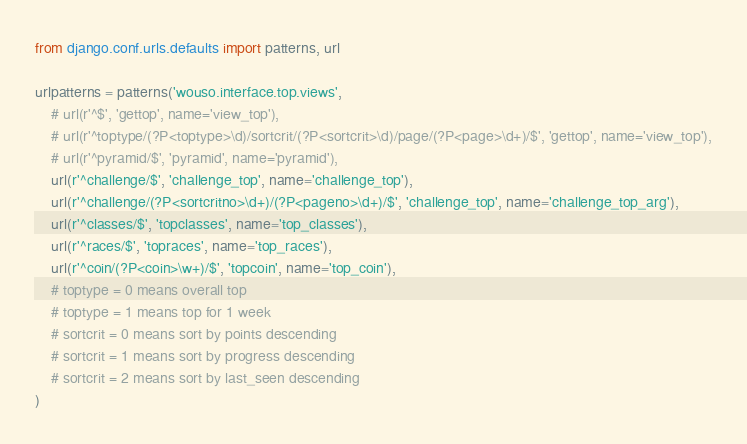Convert code to text. <code><loc_0><loc_0><loc_500><loc_500><_Python_>from django.conf.urls.defaults import patterns, url

urlpatterns = patterns('wouso.interface.top.views',
    # url(r'^$', 'gettop', name='view_top'),
    # url(r'^toptype/(?P<toptype>\d)/sortcrit/(?P<sortcrit>\d)/page/(?P<page>\d+)/$', 'gettop', name='view_top'),
    # url(r'^pyramid/$', 'pyramid', name='pyramid'),
    url(r'^challenge/$', 'challenge_top', name='challenge_top'),
    url(r'^challenge/(?P<sortcritno>\d+)/(?P<pageno>\d+)/$', 'challenge_top', name='challenge_top_arg'),
    url(r'^classes/$', 'topclasses', name='top_classes'),
    url(r'^races/$', 'topraces', name='top_races'),
    url(r'^coin/(?P<coin>\w+)/$', 'topcoin', name='top_coin'),
    # toptype = 0 means overall top
    # toptype = 1 means top for 1 week
    # sortcrit = 0 means sort by points descending
    # sortcrit = 1 means sort by progress descending
    # sortcrit = 2 means sort by last_seen descending
)
</code> 